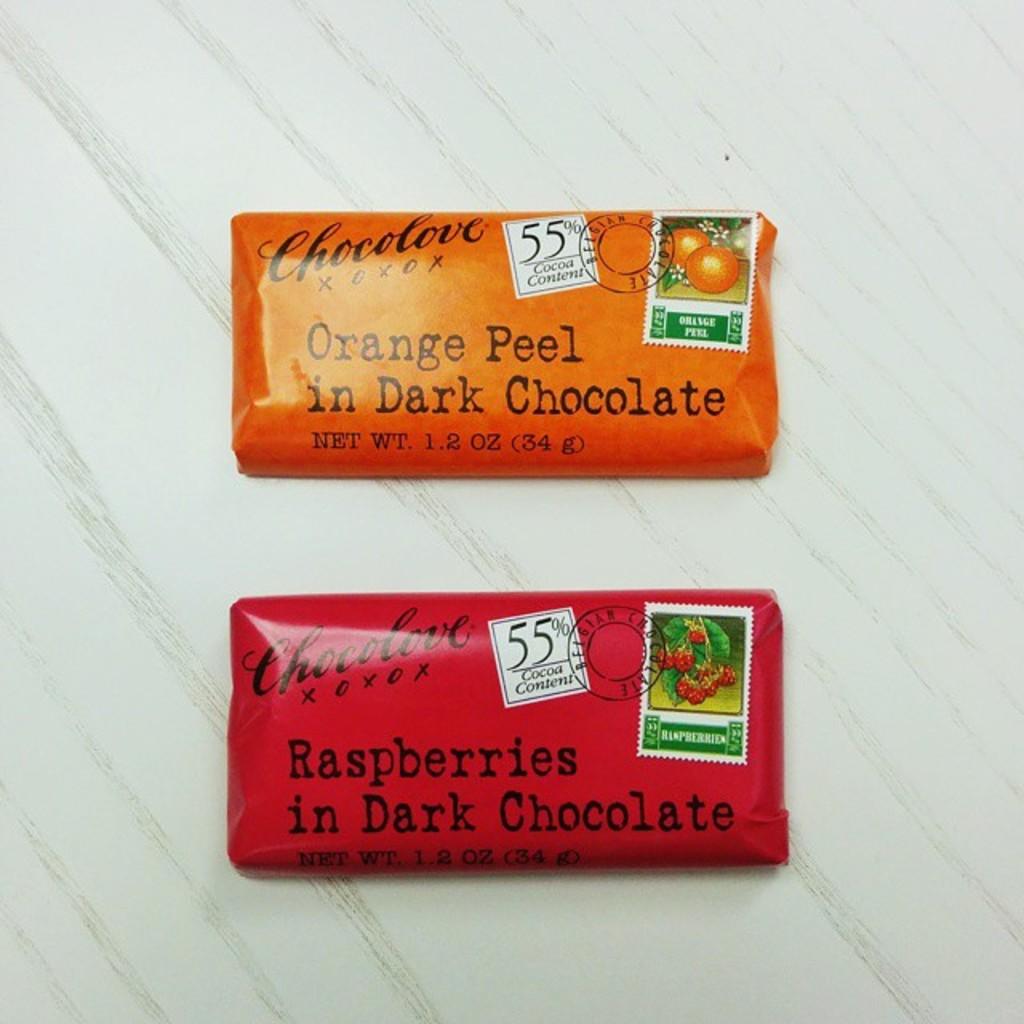What flavor is the chocolate on the top?
Your answer should be very brief. Orange peel in dark chocolate. 